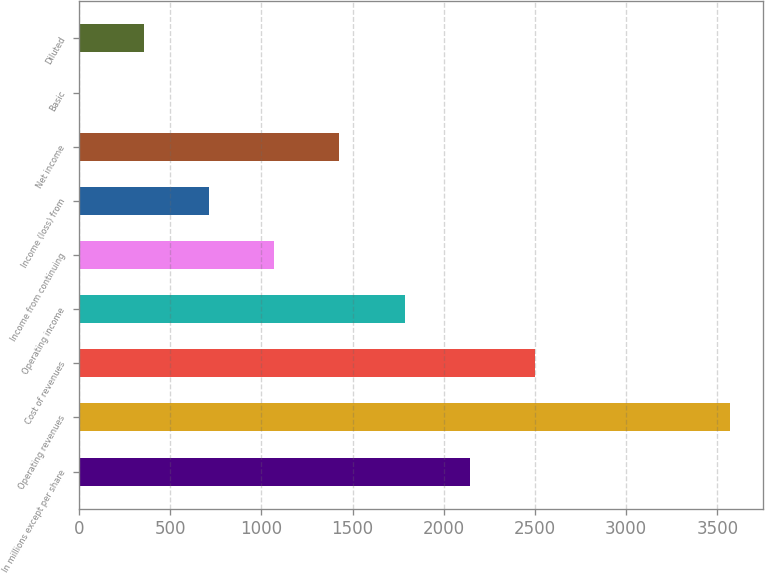Convert chart. <chart><loc_0><loc_0><loc_500><loc_500><bar_chart><fcel>In millions except per share<fcel>Operating revenues<fcel>Cost of revenues<fcel>Operating income<fcel>Income from continuing<fcel>Income (loss) from<fcel>Net income<fcel>Basic<fcel>Diluted<nl><fcel>2141.81<fcel>3569<fcel>2498.61<fcel>1785.01<fcel>1071.41<fcel>714.61<fcel>1428.21<fcel>1.01<fcel>357.81<nl></chart> 